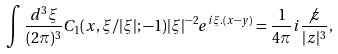<formula> <loc_0><loc_0><loc_500><loc_500>\int \frac { d ^ { 3 } \xi } { ( 2 \pi ) ^ { 3 } } C _ { 1 } ( x , \xi / | \xi | ; - 1 ) | \xi | ^ { - 2 } e ^ { i \xi . ( x - y ) } = \frac { 1 } { 4 \pi } i \frac { \not z } { | z | ^ { 3 } } ,</formula> 